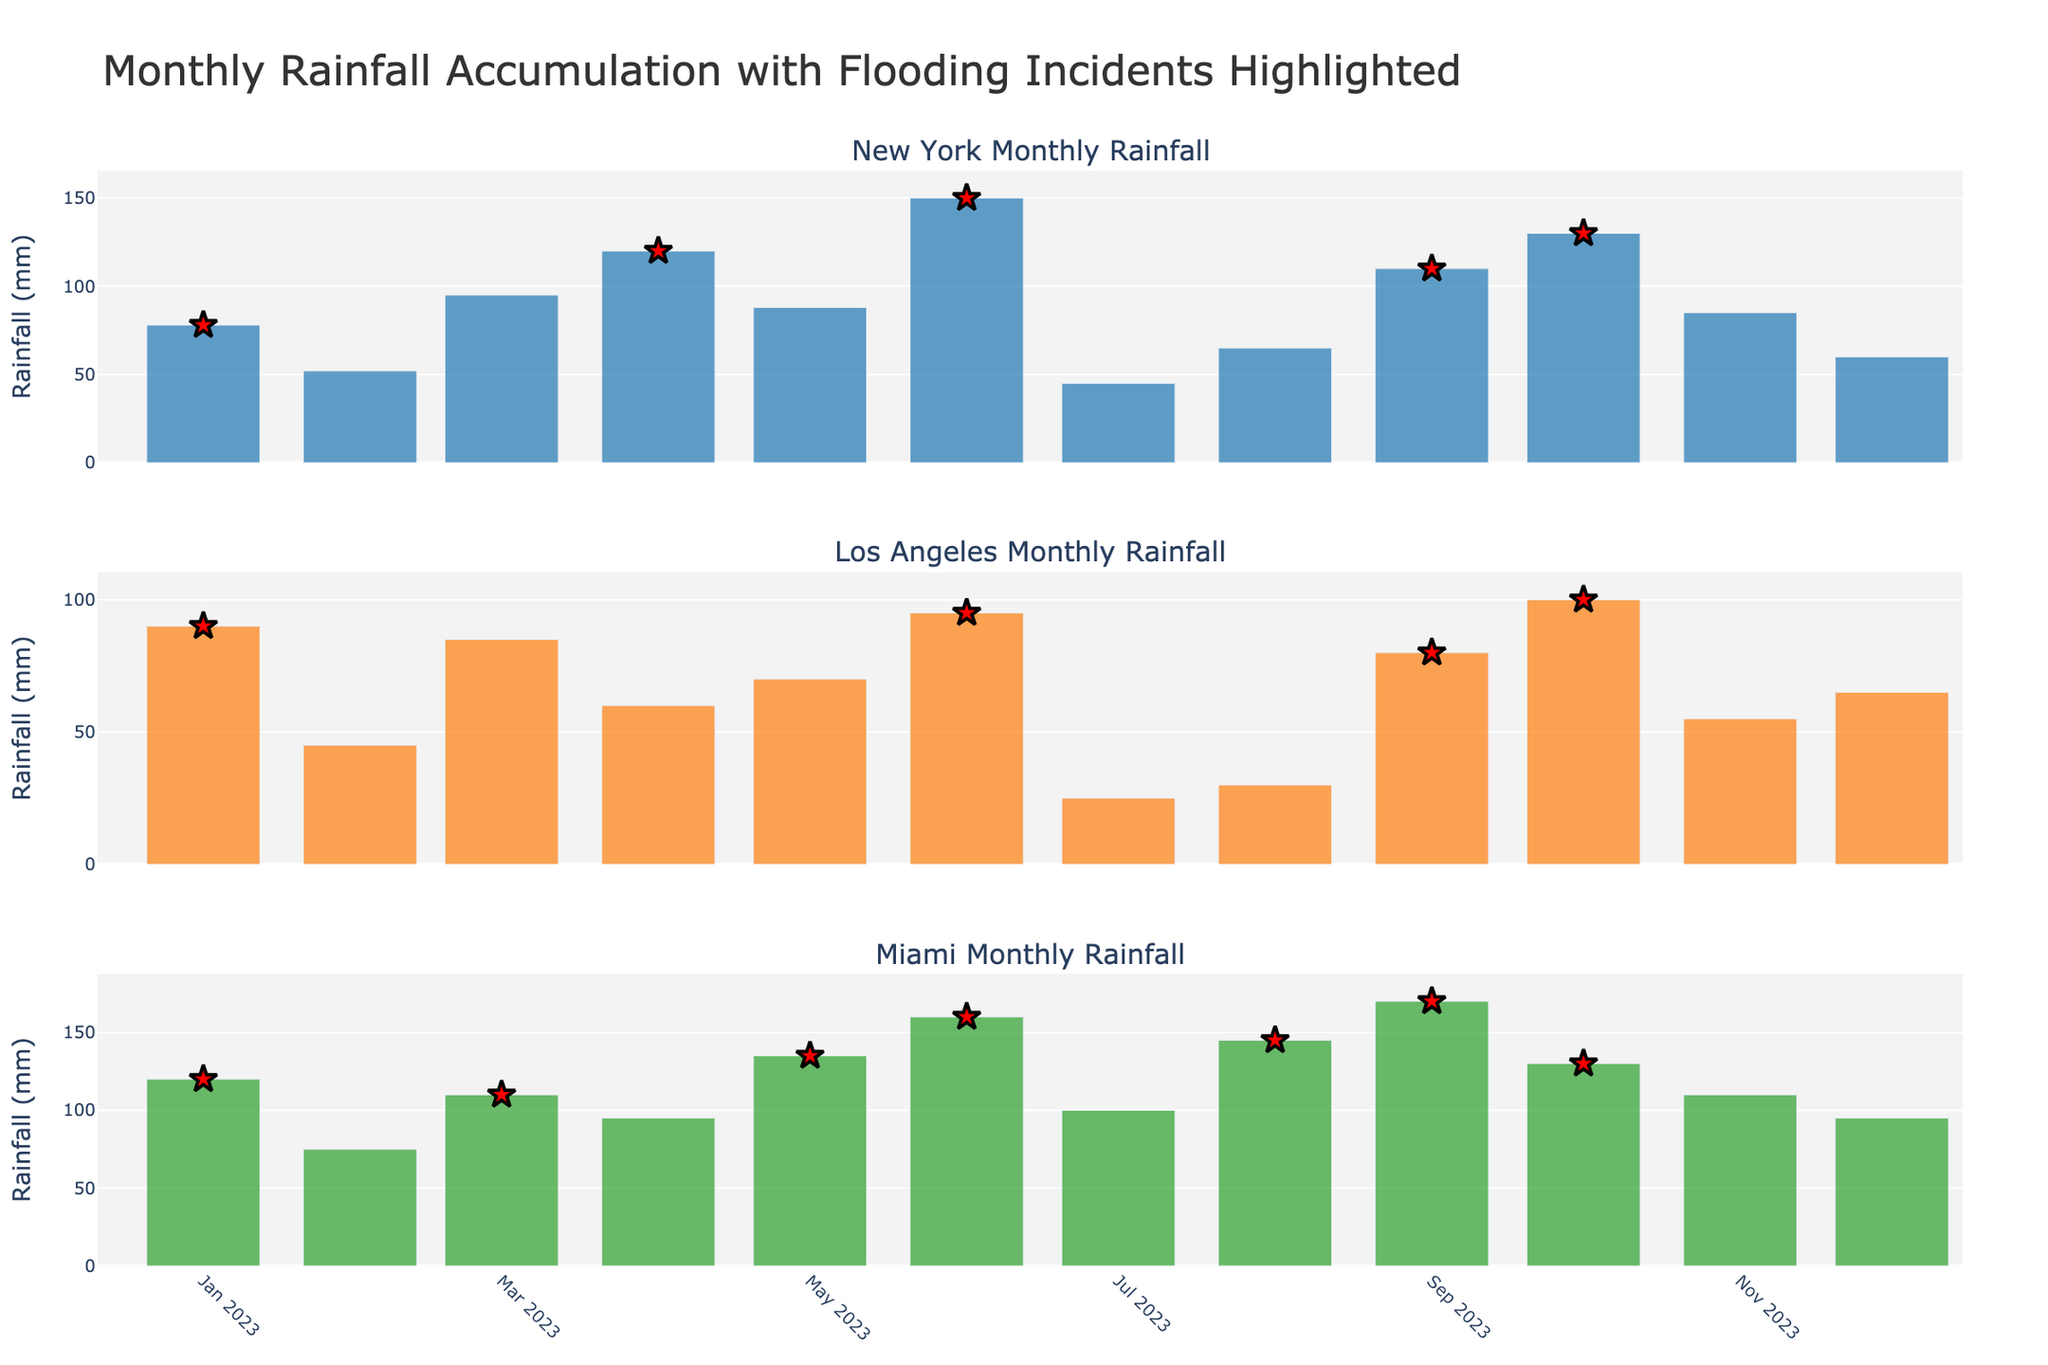What is the title of the figure? The title is displayed at the top of the figure, providing an overview of the content. It reads "Monthly Rainfall Accumulation with Flooding Incidents Highlighted."
Answer: Monthly Rainfall Accumulation with Flooding Incidents Highlighted Which city had the highest rainfall in June 2023? By examining the June 2023 data points for each city, it's clear that New York had the highest bar, indicating the most rainfall.
Answer: New York How many months experienced flooding in Miami? By counting the red star markers in the Miami subplot, you can determine the number of months that experienced flooding incidents. There are 7 such markers in Miami's graph.
Answer: 7 What is the overall trend of rainfall in Los Angeles throughout 2023? Observing the bar heights in Los Angeles' subplot, we notice a general increase in rainfall up to January, followed by a dip in the middle of the year, and another rise towards the end of 2023.
Answer: Increasing then decreasing, followed by increasing again Which month had the lowest rainfall in New York, and what value was it? By looking at the shortest bar in the New York plot, you identify that July had the lowest rainfall at 45 mm.
Answer: July, 45 mm Compare the rainfall amounts in November 2023 for New York, Los Angeles, and Miami. Which city had the highest and which had the lowest? November 2023 rainfall for each city can be identified by the bar heights: New York (85 mm), Los Angeles (55 mm), and Miami (110 mm). Miami had the highest, and Los Angeles had the lowest.
Answer: Highest: Miami, Lowest: Los Angeles For which city and month did the highest rainfall with a flooding incident occur? To find this, look for the tallest bar with a red star. Miami in September shows the highest combined value of 170 mm.
Answer: Miami, September Is there a month where all three cities experienced flooding? Check if the red star markers align vertically across the subplots. In January 2023, all three cities have a red star marker.
Answer: Yes, January 2023 What months had over 100 mm of rainfall in New York? Identify the months with bars exceeding 100 mm in height. For New York, these months are April (120 mm), June (150 mm), September (110 mm), and October (130 mm).
Answer: April, June, September, October How does July 2023's rainfall in New York compare with that of Miami? Compare the bar heights for July 2023 in New York and Miami. New York has 45 mm, whereas Miami has 100 mm, indicating Miami had substantially more rain.
Answer: Miami had more than New York 